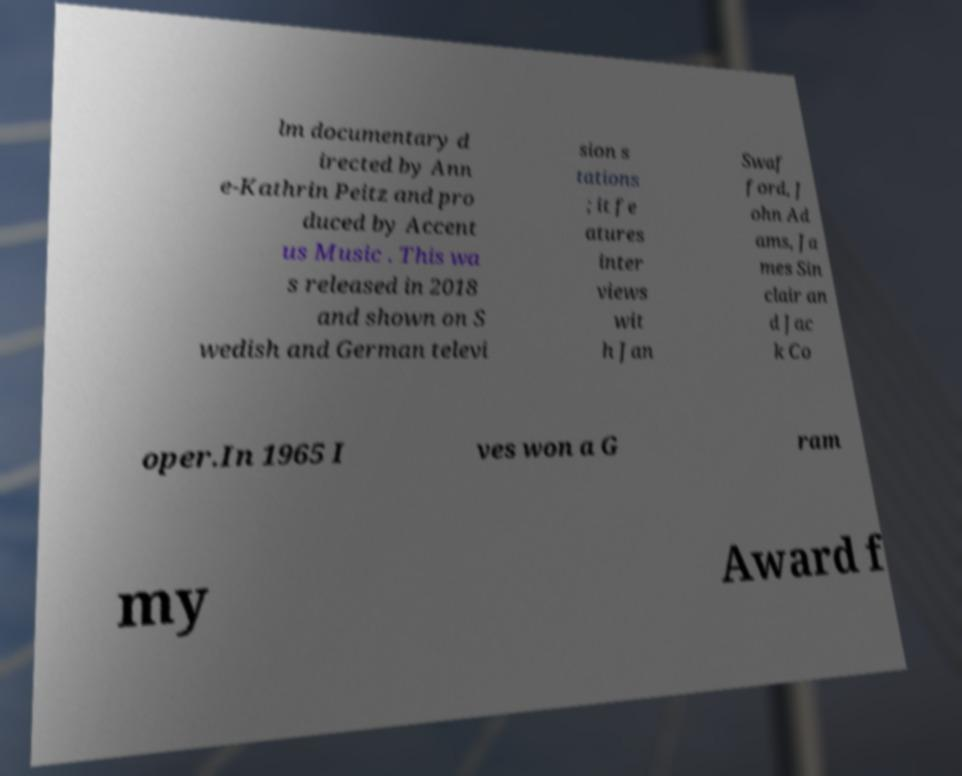Please identify and transcribe the text found in this image. lm documentary d irected by Ann e-Kathrin Peitz and pro duced by Accent us Music . This wa s released in 2018 and shown on S wedish and German televi sion s tations ; it fe atures inter views wit h Jan Swaf ford, J ohn Ad ams, Ja mes Sin clair an d Jac k Co oper.In 1965 I ves won a G ram my Award f 